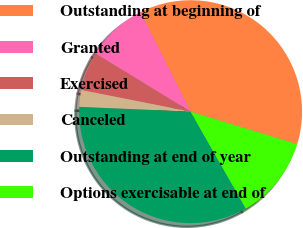Convert chart to OTSL. <chart><loc_0><loc_0><loc_500><loc_500><pie_chart><fcel>Outstanding at beginning of<fcel>Granted<fcel>Exercised<fcel>Canceled<fcel>Outstanding at end of year<fcel>Options exercisable at end of<nl><fcel>37.13%<fcel>8.84%<fcel>5.63%<fcel>2.43%<fcel>33.93%<fcel>12.04%<nl></chart> 